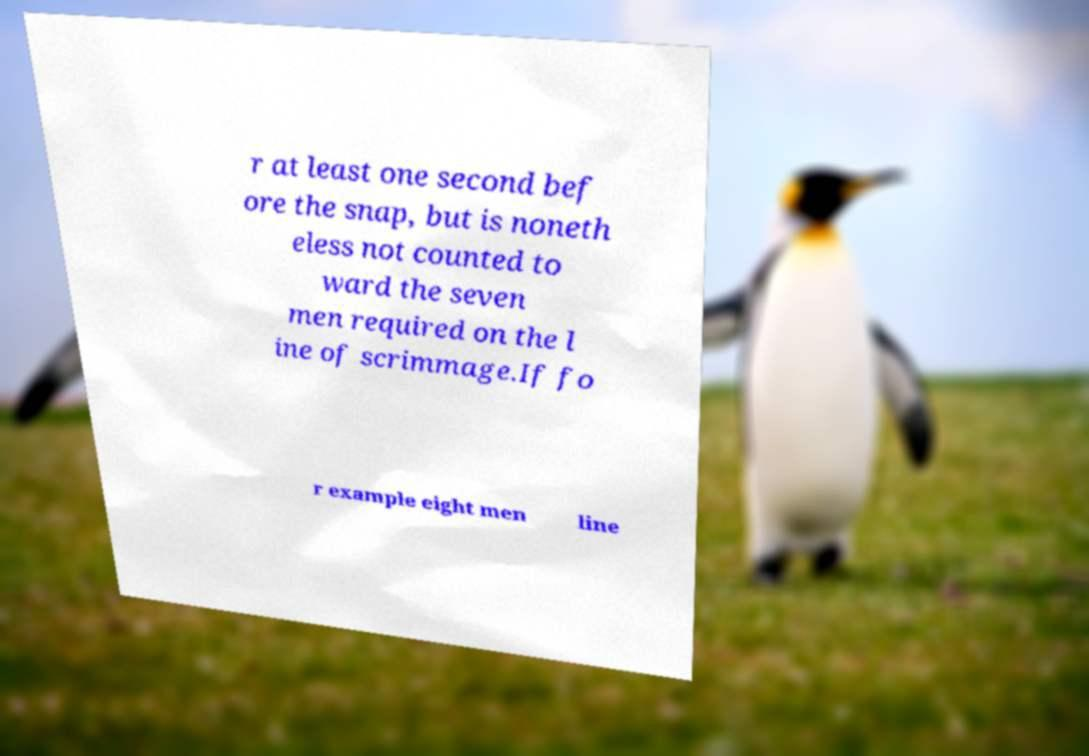There's text embedded in this image that I need extracted. Can you transcribe it verbatim? r at least one second bef ore the snap, but is noneth eless not counted to ward the seven men required on the l ine of scrimmage.If fo r example eight men line 